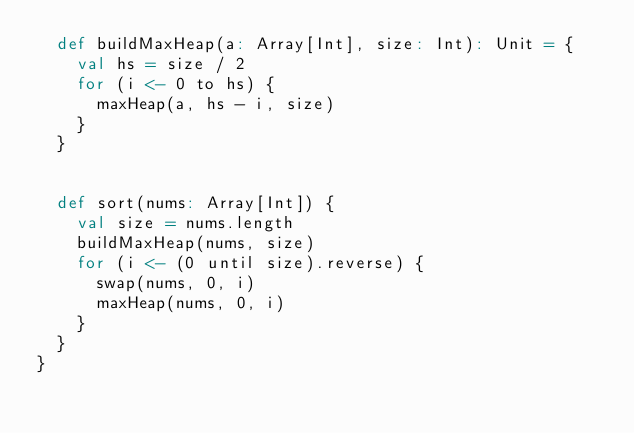<code> <loc_0><loc_0><loc_500><loc_500><_Scala_>  def buildMaxHeap(a: Array[Int], size: Int): Unit = {
    val hs = size / 2
    for (i <- 0 to hs) {
      maxHeap(a, hs - i, size)
    }
  }


  def sort(nums: Array[Int]) {
    val size = nums.length
    buildMaxHeap(nums, size)
    for (i <- (0 until size).reverse) {
      swap(nums, 0, i)
      maxHeap(nums, 0, i)
    }
  }
}

</code> 